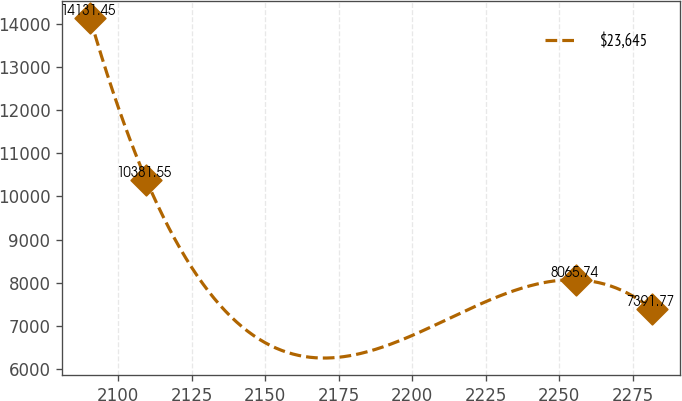Convert chart to OTSL. <chart><loc_0><loc_0><loc_500><loc_500><line_chart><ecel><fcel>$23,645<nl><fcel>2090.47<fcel>14131.5<nl><fcel>2109.56<fcel>10381.5<nl><fcel>2255.75<fcel>8065.74<nl><fcel>2281.39<fcel>7391.77<nl></chart> 